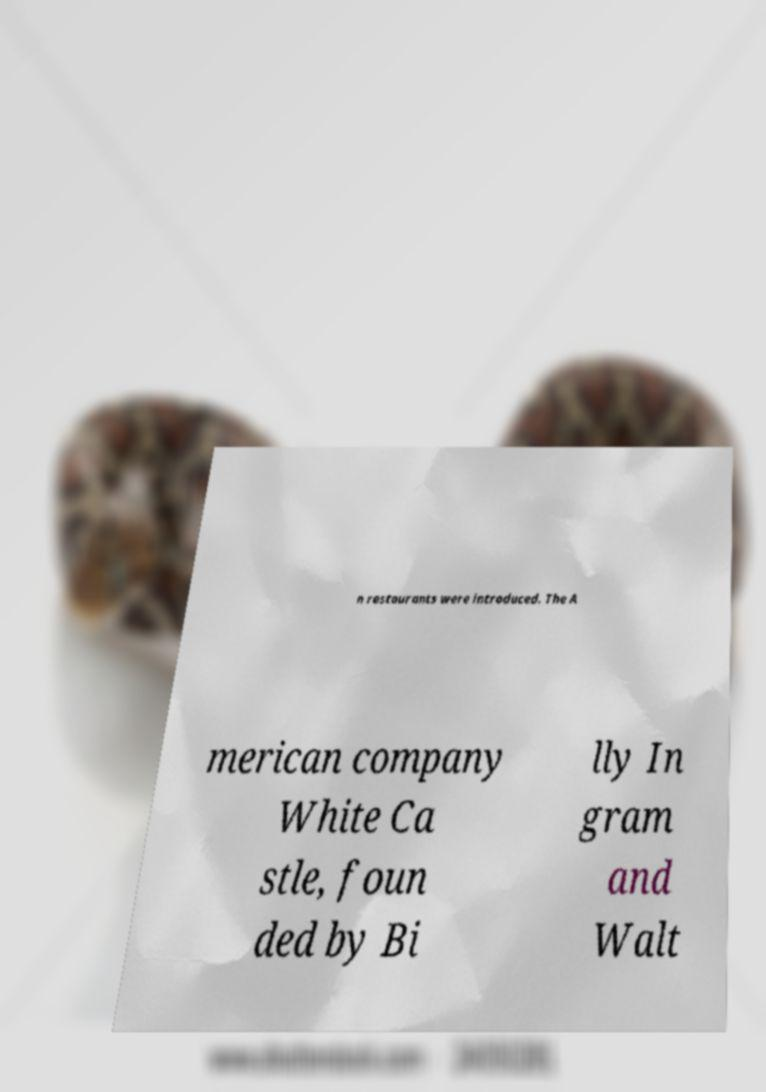What messages or text are displayed in this image? I need them in a readable, typed format. n restaurants were introduced. The A merican company White Ca stle, foun ded by Bi lly In gram and Walt 